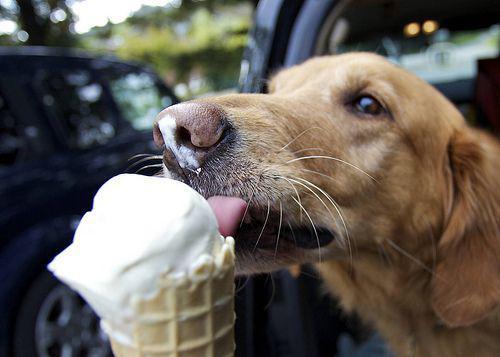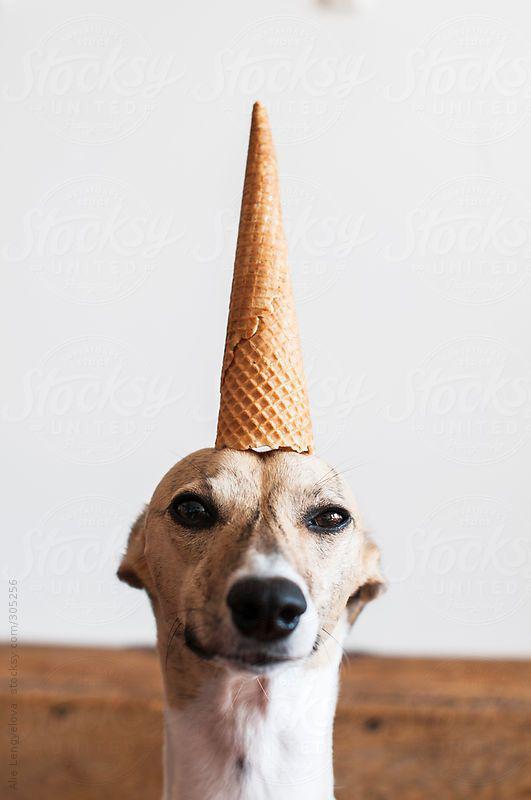The first image is the image on the left, the second image is the image on the right. Analyze the images presented: Is the assertion "At least one of the images includes a dog interacting with an ice cream cone." valid? Answer yes or no. Yes. The first image is the image on the left, the second image is the image on the right. Examine the images to the left and right. Is the description "There is two dogs in the right image." accurate? Answer yes or no. No. 